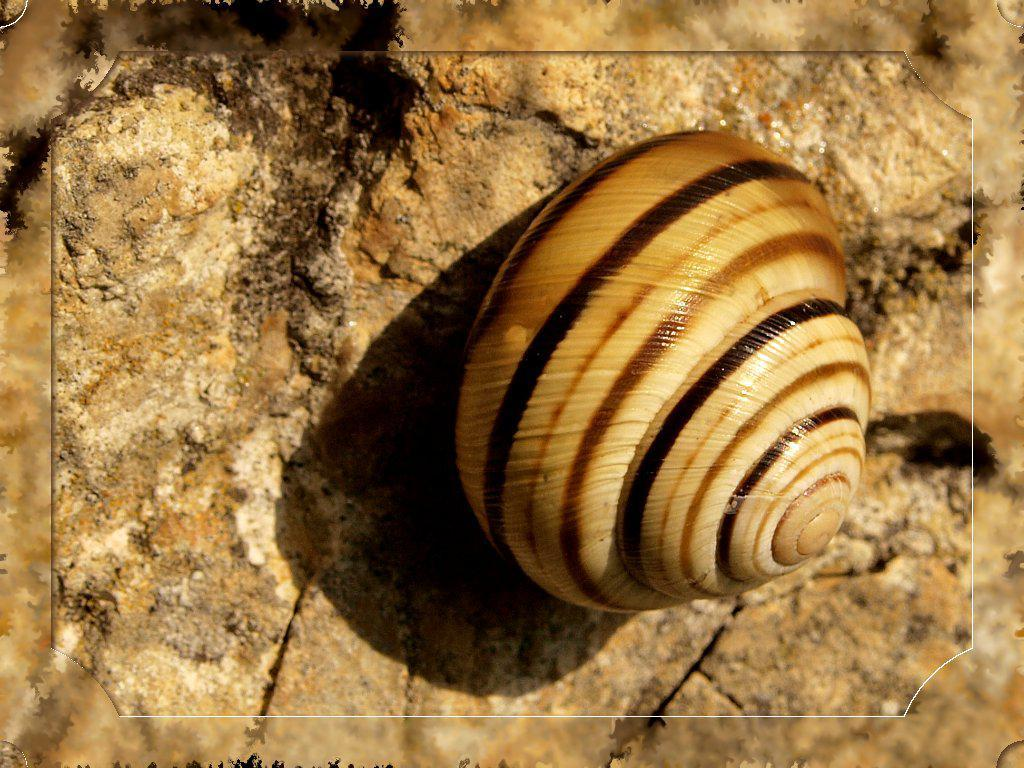What is the main object in the image? There is a shell in the image. Where is the shell located? The shell is on a stone surface. What part of the image does the shell occupy? The shell is in the foreground of the image. What type of feast is being prepared on the island in the image? There is no island or feast present in the image; it features a shell on a stone surface. Can you describe the person holding the shell in the image? There is no person present in the image; it only features a shell on a stone surface. 